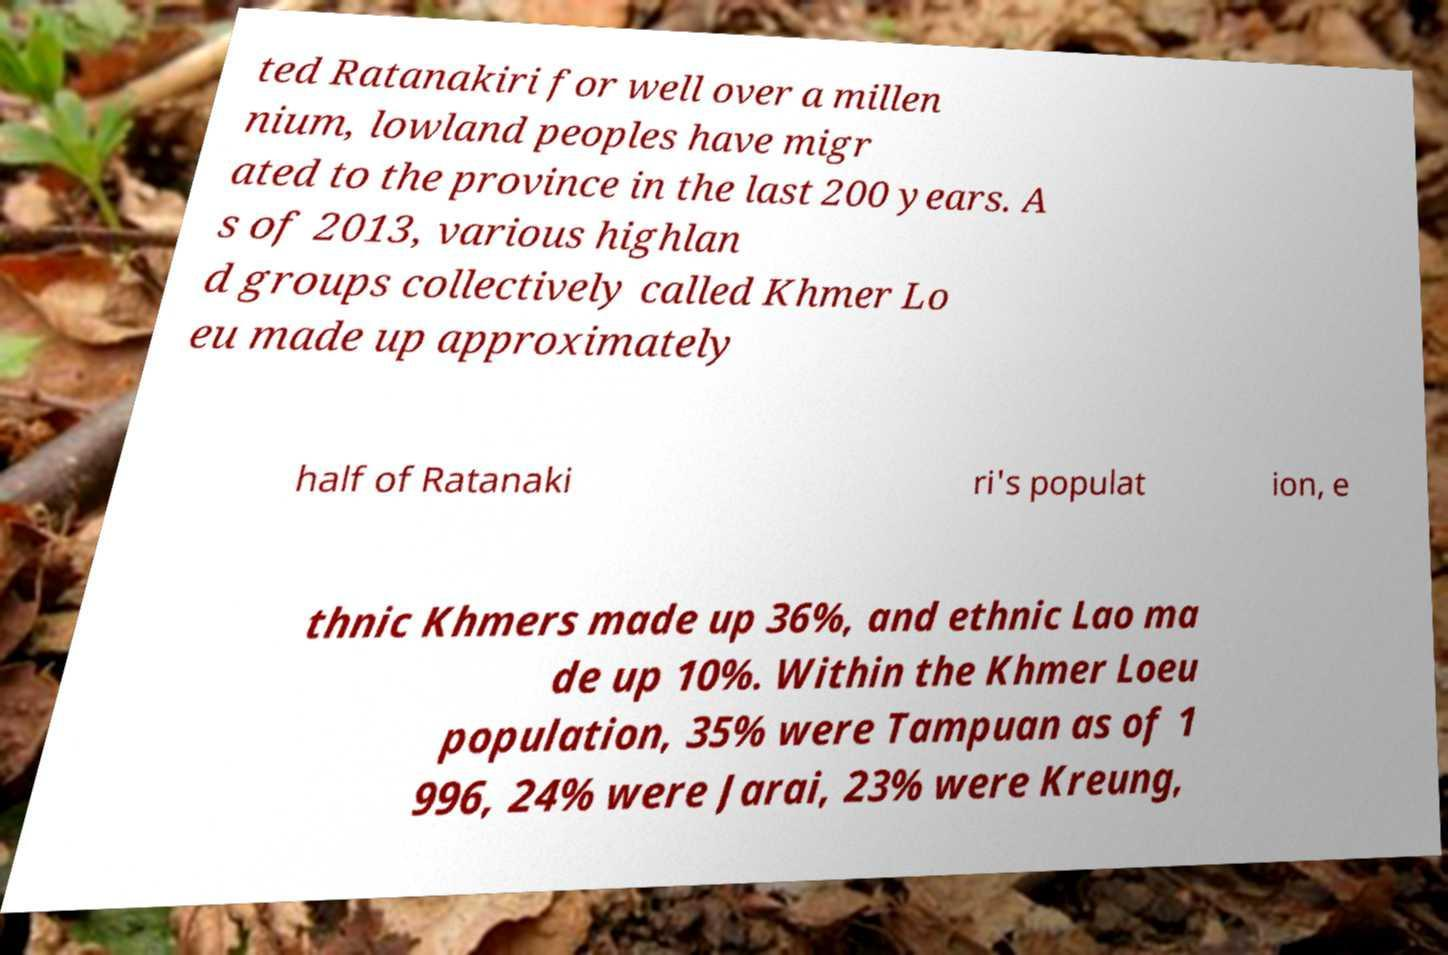Could you assist in decoding the text presented in this image and type it out clearly? ted Ratanakiri for well over a millen nium, lowland peoples have migr ated to the province in the last 200 years. A s of 2013, various highlan d groups collectively called Khmer Lo eu made up approximately half of Ratanaki ri's populat ion, e thnic Khmers made up 36%, and ethnic Lao ma de up 10%. Within the Khmer Loeu population, 35% were Tampuan as of 1 996, 24% were Jarai, 23% were Kreung, 